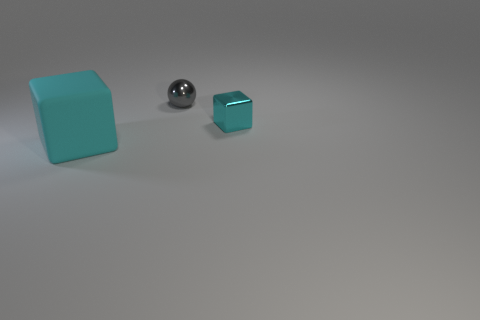Is there any other thing that is the same size as the rubber thing?
Make the answer very short. No. Are there fewer gray spheres that are to the right of the small metal block than large things in front of the gray thing?
Offer a terse response. Yes. How big is the cyan cube that is on the left side of the small gray thing?
Your response must be concise. Large. Is the cyan shiny cube the same size as the rubber thing?
Offer a very short reply. No. How many things are both in front of the ball and on the left side of the tiny cube?
Your answer should be very brief. 1. What number of gray objects are shiny things or matte objects?
Your response must be concise. 1. What number of shiny things are either small red objects or cyan things?
Ensure brevity in your answer.  1. Are there any big purple objects?
Provide a succinct answer. No. Does the gray thing have the same shape as the big matte object?
Offer a very short reply. No. How many rubber objects are behind the cyan thing on the right side of the small object behind the tiny cyan thing?
Your answer should be compact. 0. 